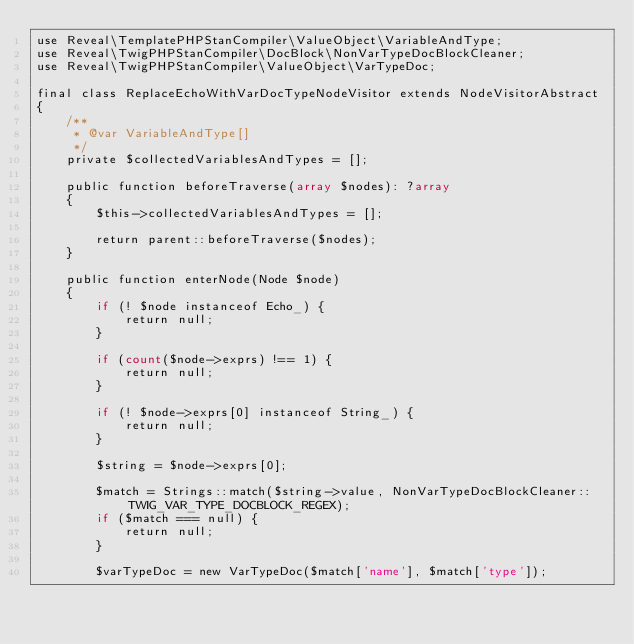<code> <loc_0><loc_0><loc_500><loc_500><_PHP_>use Reveal\TemplatePHPStanCompiler\ValueObject\VariableAndType;
use Reveal\TwigPHPStanCompiler\DocBlock\NonVarTypeDocBlockCleaner;
use Reveal\TwigPHPStanCompiler\ValueObject\VarTypeDoc;

final class ReplaceEchoWithVarDocTypeNodeVisitor extends NodeVisitorAbstract
{
    /**
     * @var VariableAndType[]
     */
    private $collectedVariablesAndTypes = [];

    public function beforeTraverse(array $nodes): ?array
    {
        $this->collectedVariablesAndTypes = [];

        return parent::beforeTraverse($nodes);
    }

    public function enterNode(Node $node)
    {
        if (! $node instanceof Echo_) {
            return null;
        }

        if (count($node->exprs) !== 1) {
            return null;
        }

        if (! $node->exprs[0] instanceof String_) {
            return null;
        }

        $string = $node->exprs[0];

        $match = Strings::match($string->value, NonVarTypeDocBlockCleaner::TWIG_VAR_TYPE_DOCBLOCK_REGEX);
        if ($match === null) {
            return null;
        }

        $varTypeDoc = new VarTypeDoc($match['name'], $match['type']);
</code> 